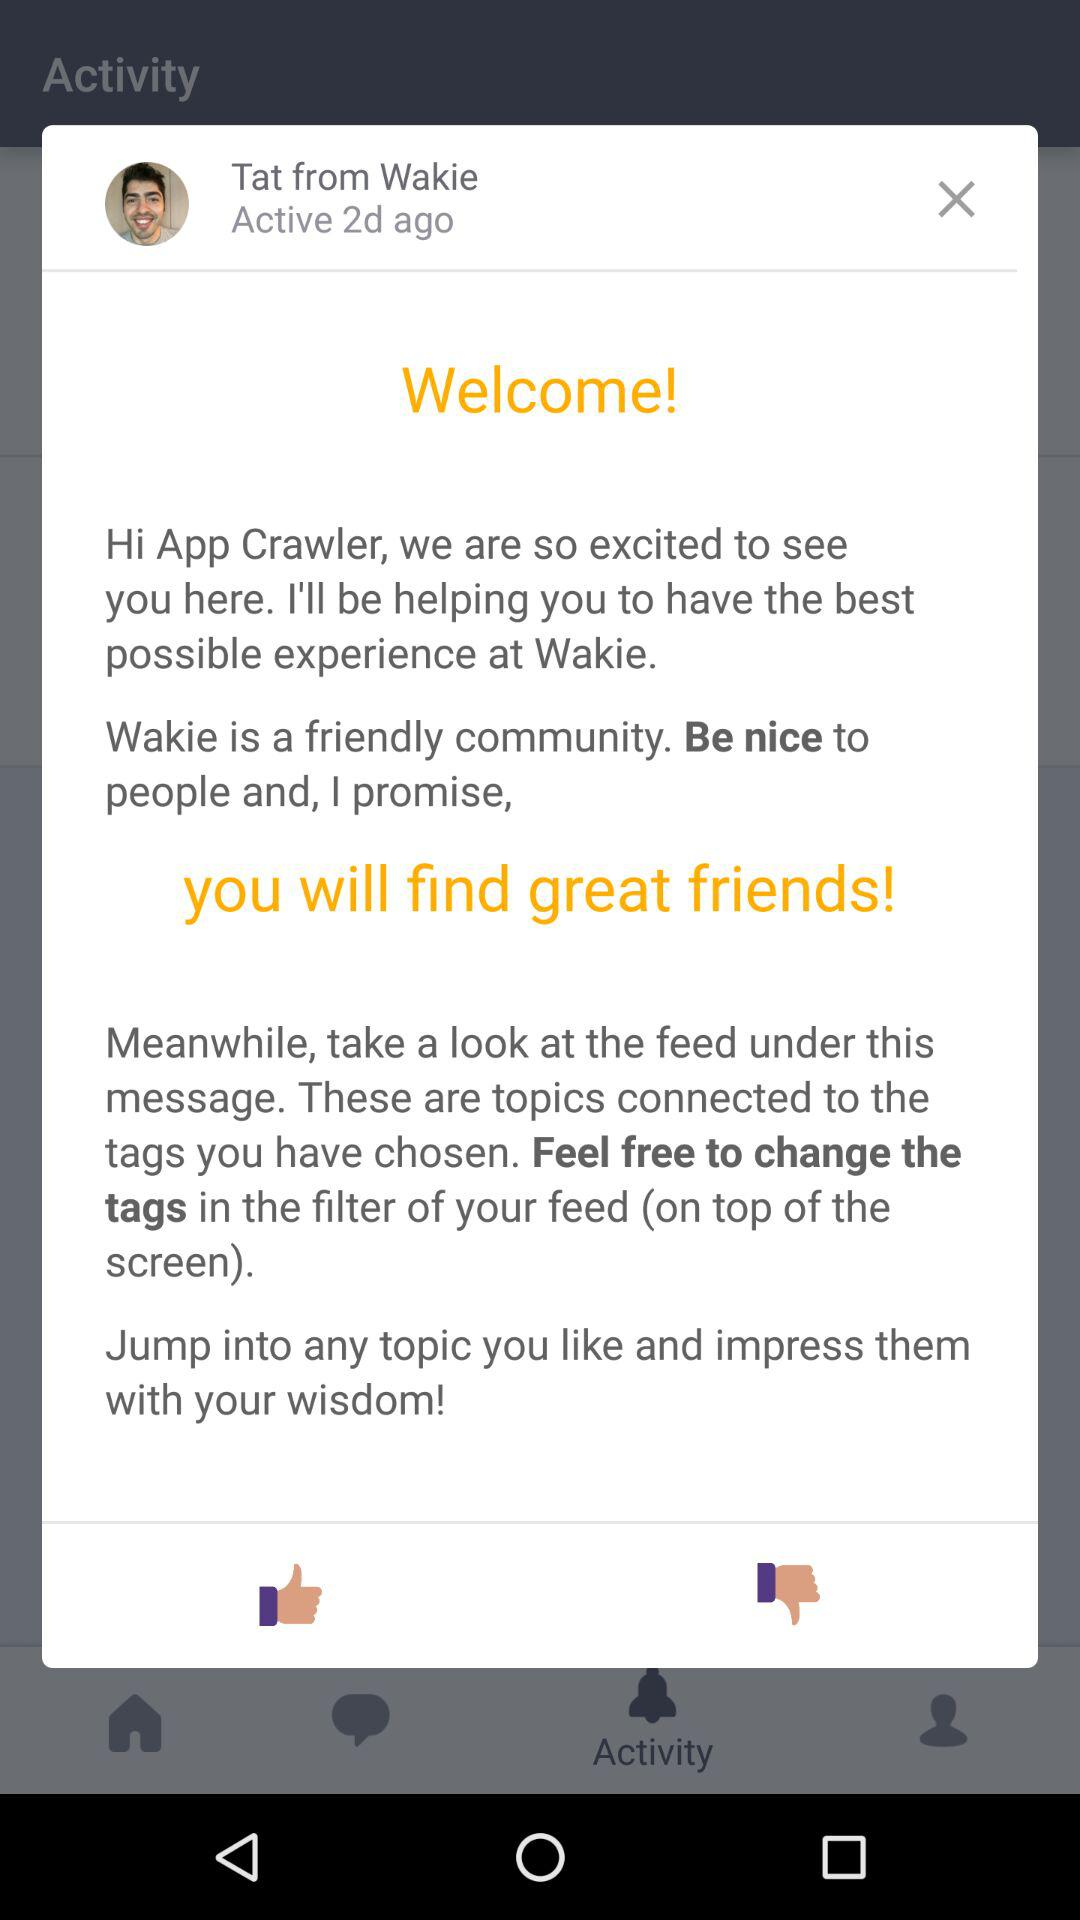How many days ago was the user active? The user was active 2 days ago. 